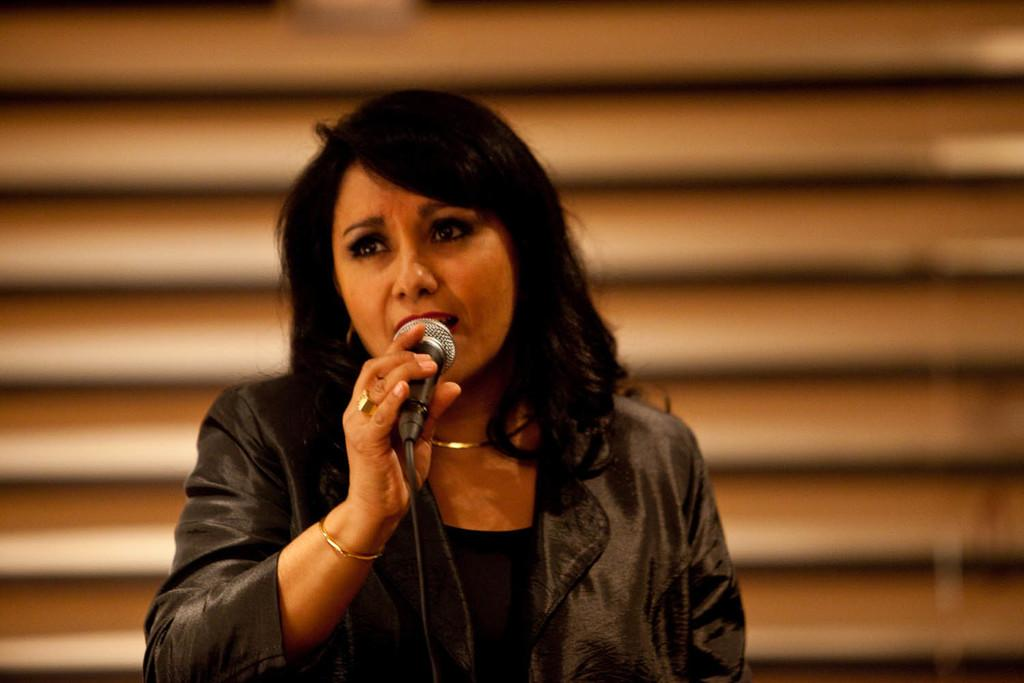What is the main subject of the image? There is a woman standing in the center of the image. What is the woman holding in the image? The woman is holding a microphone. What might the woman be doing with the microphone? It appears that the woman is singing. Can you describe the background of the image? There might be a window in the background of the image. What type of root can be seen growing from the woman's head in the image? There is no root growing from the woman's head in the image. What action is the expansion performing in the image? There is no action called "expansion" present in the image. 